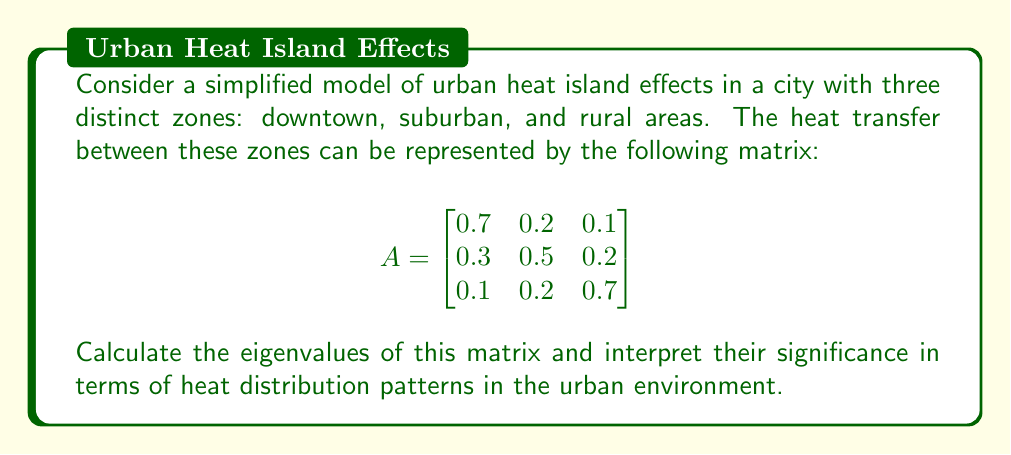Teach me how to tackle this problem. To find the eigenvalues of matrix A, we need to solve the characteristic equation:

$$\det(A - \lambda I) = 0$$

Step 1: Set up the characteristic equation
$$\begin{vmatrix}
0.7 - \lambda & 0.2 & 0.1 \\
0.3 & 0.5 - \lambda & 0.2 \\
0.1 & 0.2 & 0.7 - \lambda
\end{vmatrix} = 0$$

Step 2: Expand the determinant
$$(0.7 - \lambda)[(0.5 - \lambda)(0.7 - \lambda) - 0.04] - 0.2[0.3(0.7 - \lambda) - 0.02] + 0.1[0.06 - 0.3(0.5 - \lambda)] = 0$$

Step 3: Simplify
$$-\lambda^3 + 1.9\lambda^2 - 0.83\lambda + 0 = 0$$

Step 4: Solve the cubic equation
Using the cubic formula or a numerical method, we find the roots:

$\lambda_1 = 1$
$\lambda_2 \approx 0.5789$
$\lambda_3 \approx 0.3211$

Interpretation:
1. The largest eigenvalue ($\lambda_1 = 1$) represents the steady-state heat distribution. It indicates that the system conserves energy overall.
2. The second eigenvalue ($\lambda_2 \approx 0.5789$) represents a slower-decaying mode of heat transfer between zones.
3. The smallest eigenvalue ($\lambda_3 \approx 0.3211$) represents the fastest-decaying mode, indicating rapid initial adjustments in heat distribution.

These eigenvalues show how heat is distributed and transferred between urban zones over time, with the urban heat island effect persisting due to the non-zero eigenvalues less than 1.
Answer: Eigenvalues: 1, 0.5789, 0.3211 (approximate) 